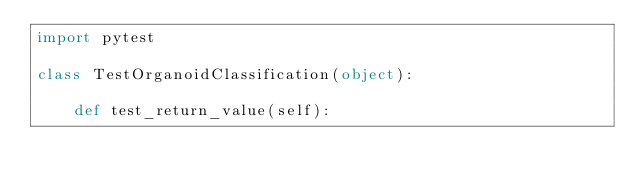Convert code to text. <code><loc_0><loc_0><loc_500><loc_500><_Python_>import pytest

class TestOrganoidClassification(object):

    def test_return_value(self):</code> 